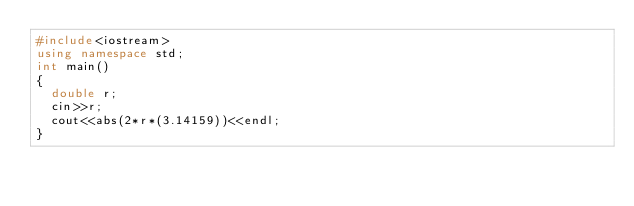Convert code to text. <code><loc_0><loc_0><loc_500><loc_500><_C++_>#include<iostream>
using namespace std;
int main()
{
  double r;
  cin>>r;
  cout<<abs(2*r*(3.14159))<<endl;
}

</code> 